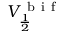<formula> <loc_0><loc_0><loc_500><loc_500>V _ { \frac { 1 } { 2 } } ^ { b i f }</formula> 